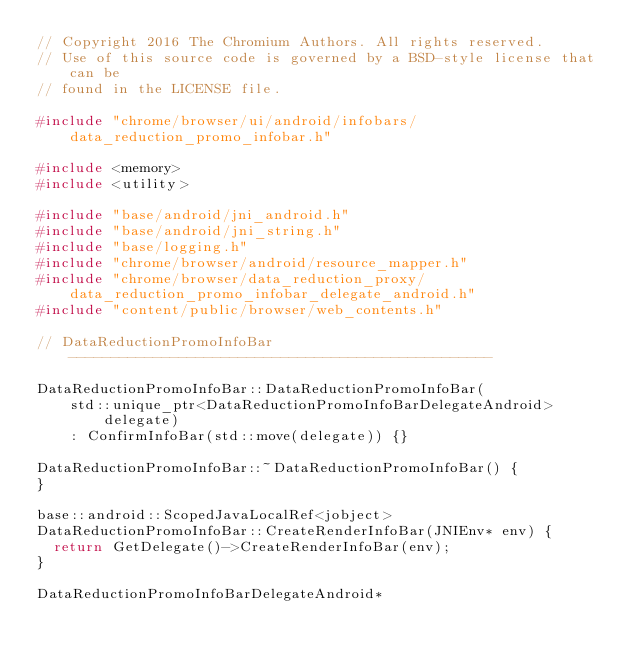Convert code to text. <code><loc_0><loc_0><loc_500><loc_500><_C++_>// Copyright 2016 The Chromium Authors. All rights reserved.
// Use of this source code is governed by a BSD-style license that can be
// found in the LICENSE file.

#include "chrome/browser/ui/android/infobars/data_reduction_promo_infobar.h"

#include <memory>
#include <utility>

#include "base/android/jni_android.h"
#include "base/android/jni_string.h"
#include "base/logging.h"
#include "chrome/browser/android/resource_mapper.h"
#include "chrome/browser/data_reduction_proxy/data_reduction_promo_infobar_delegate_android.h"
#include "content/public/browser/web_contents.h"

// DataReductionPromoInfoBar --------------------------------------------------

DataReductionPromoInfoBar::DataReductionPromoInfoBar(
    std::unique_ptr<DataReductionPromoInfoBarDelegateAndroid> delegate)
    : ConfirmInfoBar(std::move(delegate)) {}

DataReductionPromoInfoBar::~DataReductionPromoInfoBar() {
}

base::android::ScopedJavaLocalRef<jobject>
DataReductionPromoInfoBar::CreateRenderInfoBar(JNIEnv* env) {
  return GetDelegate()->CreateRenderInfoBar(env);
}

DataReductionPromoInfoBarDelegateAndroid*</code> 